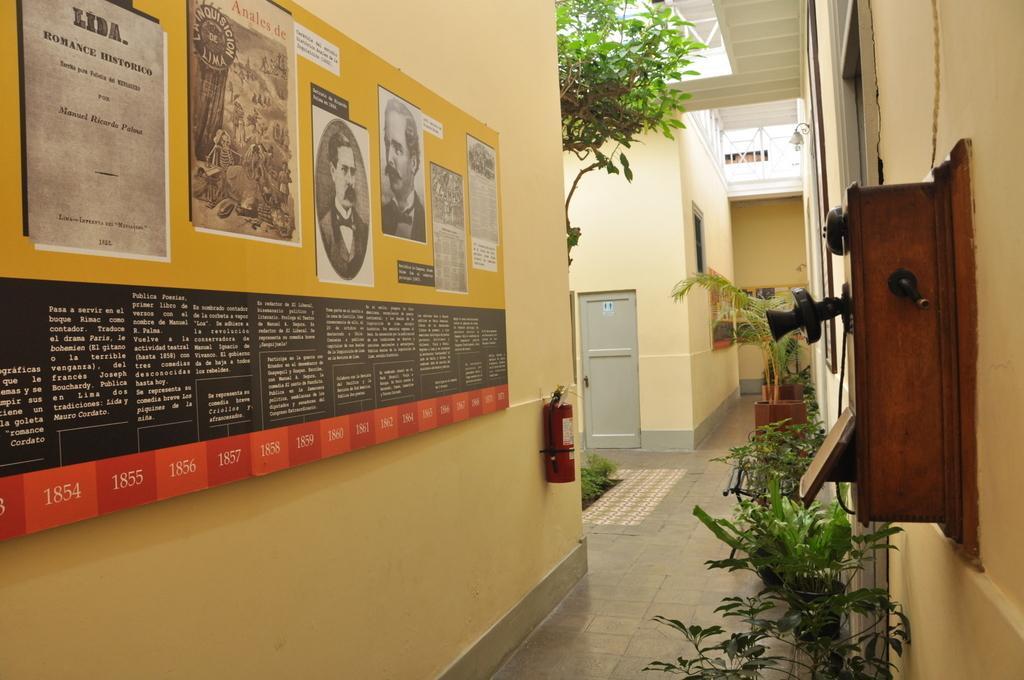In one or two sentences, can you explain what this image depicts? On the right side of this image there is a wooden box attached to the wall. At the bottom there are few plants. On the left side there is a board attached to the wall. On this board, I can see some text and few images of persons. In the background there is a tree and a door to the wall. 